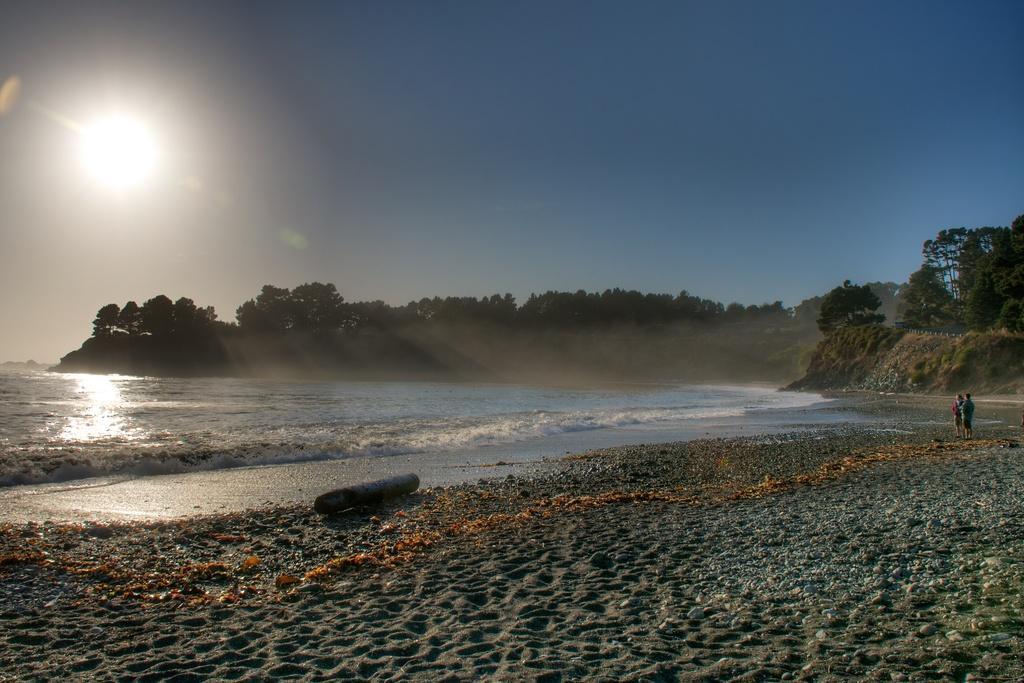Please provide a concise description of this image. In this image there is the sky, there is sun in the sky, there are trees, there are trees truncated towards the right of the image, there is sea truncated towards the left of the image, there are two persons standing, there is an object on the ground, there is sand truncated towards the bottom of the image. 